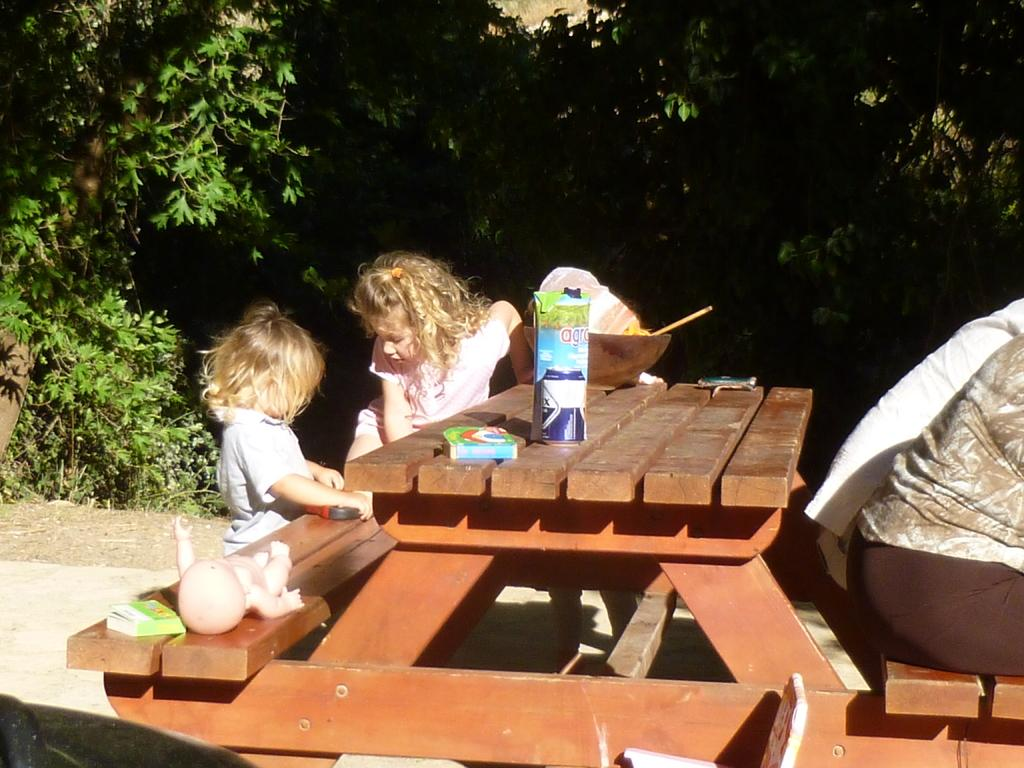What type of seating is present in the image? There is a bench in the image. How many people are sitting on the bench? Three people are seated on the bench. What else can be seen on the bench? There is a bowl on the bench. What can be seen in the background of the image? There are trees visible in the image. What type of bird can be seen in the prison in the image? There is no prison or bird present in the image. 